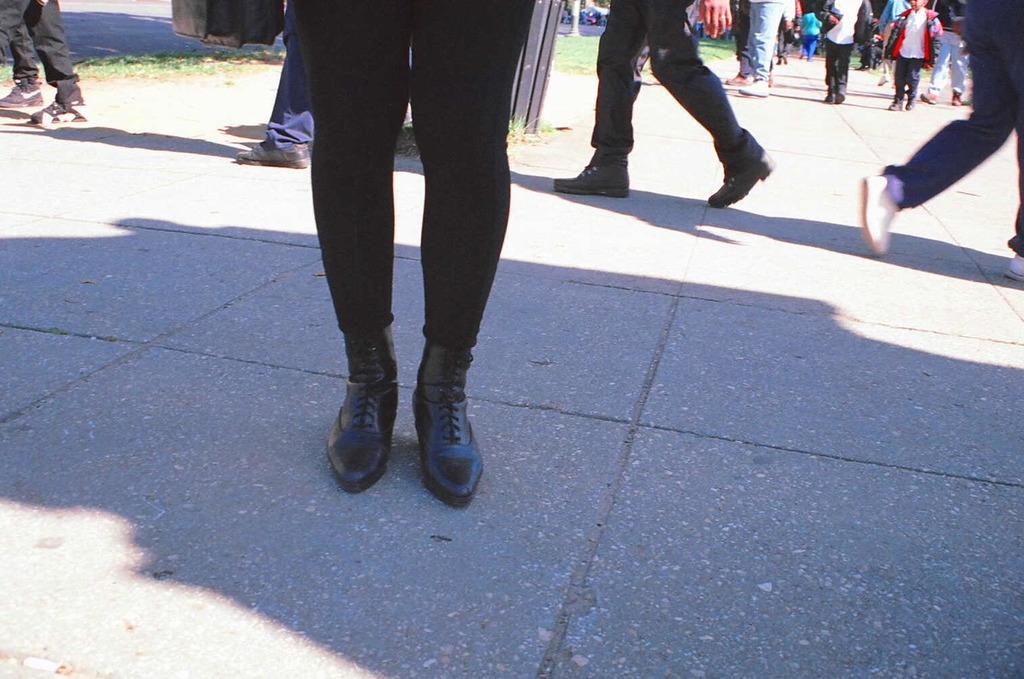Describe this image in one or two sentences. In this image we can see a few people walking and far we can see a kid wearing a red color sweater. 